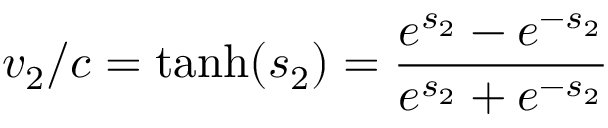<formula> <loc_0><loc_0><loc_500><loc_500>v _ { 2 } / c = { t a n h } ( s _ { 2 } ) = { \frac { e ^ { s _ { 2 } } - e ^ { - s _ { 2 } } } { e ^ { s _ { 2 } } + e ^ { - s _ { 2 } } } }</formula> 